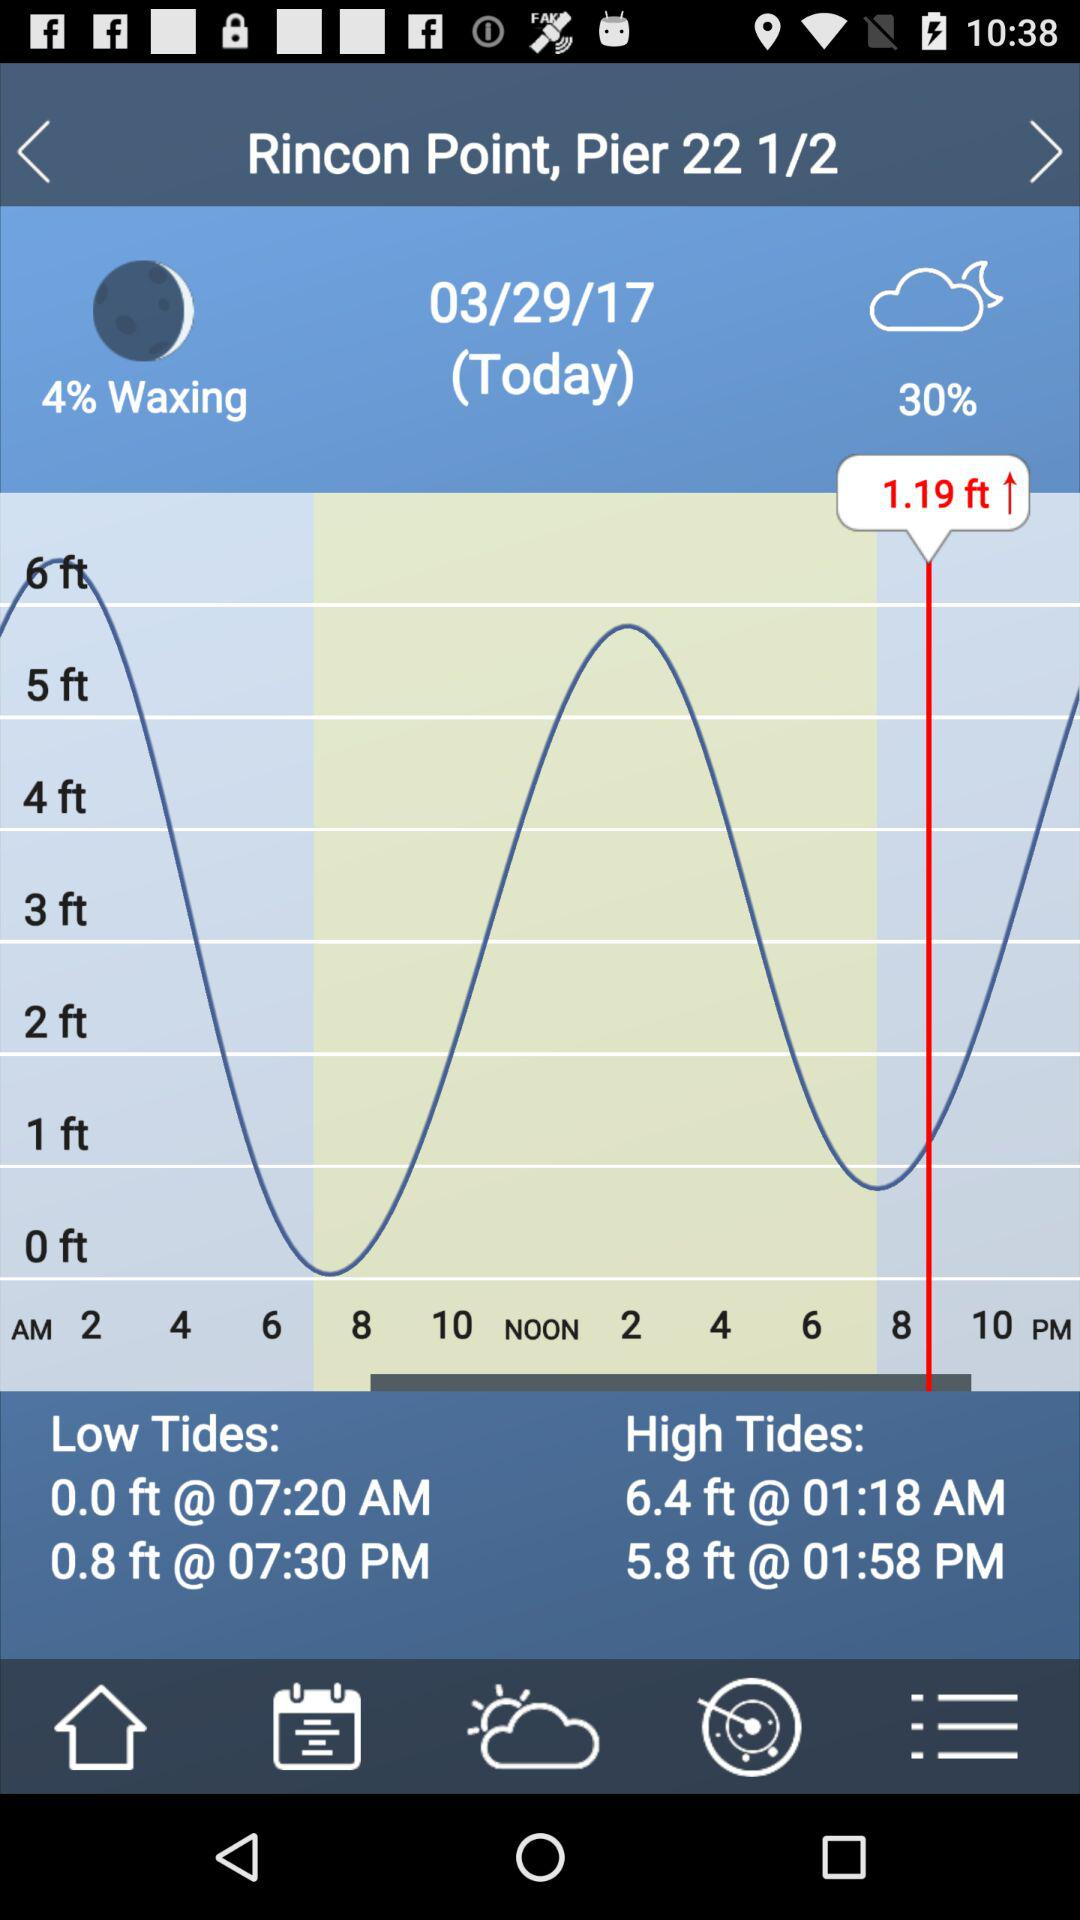What is the given date? The given date is March 29, 2017. 